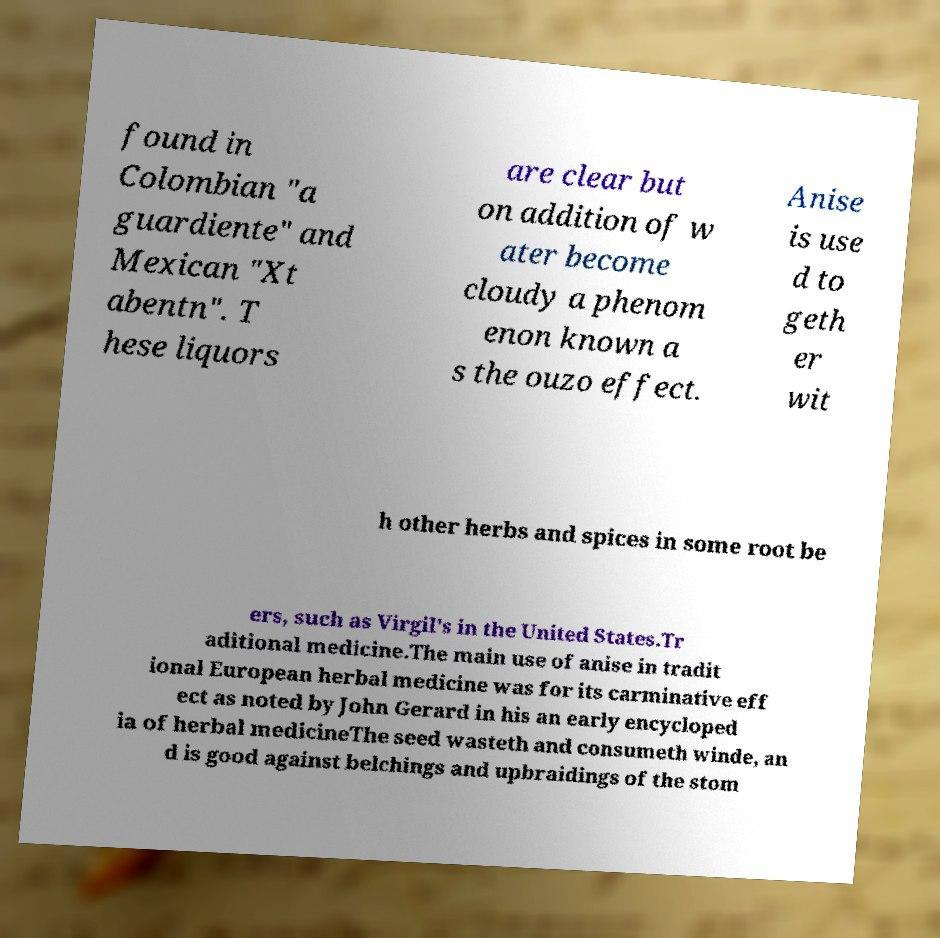For documentation purposes, I need the text within this image transcribed. Could you provide that? found in Colombian "a guardiente" and Mexican "Xt abentn". T hese liquors are clear but on addition of w ater become cloudy a phenom enon known a s the ouzo effect. Anise is use d to geth er wit h other herbs and spices in some root be ers, such as Virgil's in the United States.Tr aditional medicine.The main use of anise in tradit ional European herbal medicine was for its carminative eff ect as noted by John Gerard in his an early encycloped ia of herbal medicineThe seed wasteth and consumeth winde, an d is good against belchings and upbraidings of the stom 